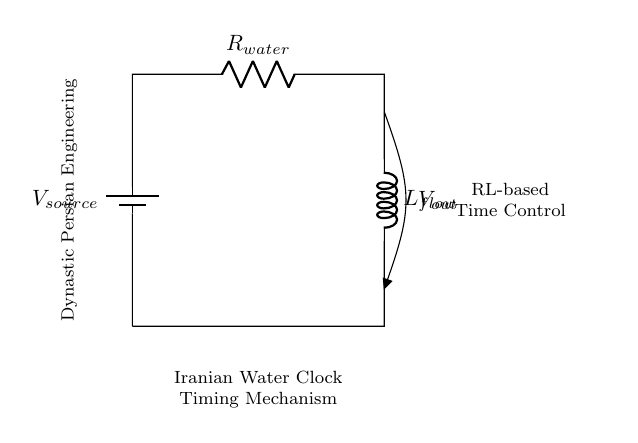What is the source voltage in the circuit? The source voltage is the value labeled near the battery component, which is denoted as V_source.
Answer: V_source What type of components are used in this timing mechanism? The components in this circuit include a battery, a resistor, and an inductor, as labeled in the diagram.
Answer: Battery, resistor, inductor What is the value of the resistor? The resistor is labeled as R_water, which indicates its purpose but does not specify a numeric value.
Answer: R_water What is the role of the inductor in this circuit? The inductor, labeled L_flow, is likely used for energy storage, influencing the timing of the mechanism by affecting the current flow.
Answer: Timing influence How does the current flow in this circuit? Current flows from the battery through the resistor to the inductor and then returns to the battery, forming a complete circuit loop.
Answer: Complete circuit loop What effect does increasing the resistance have on the timing mechanism? Increasing the resistance will decrease the current flow, which can affect the timing delays in the mechanism, as per the RL circuit behavior.
Answer: Decrease current flow What does V_out indicate in this circuit? V_out represents the output voltage across the inductor and is related to the timing control of the water clock mechanism.
Answer: Output voltage 